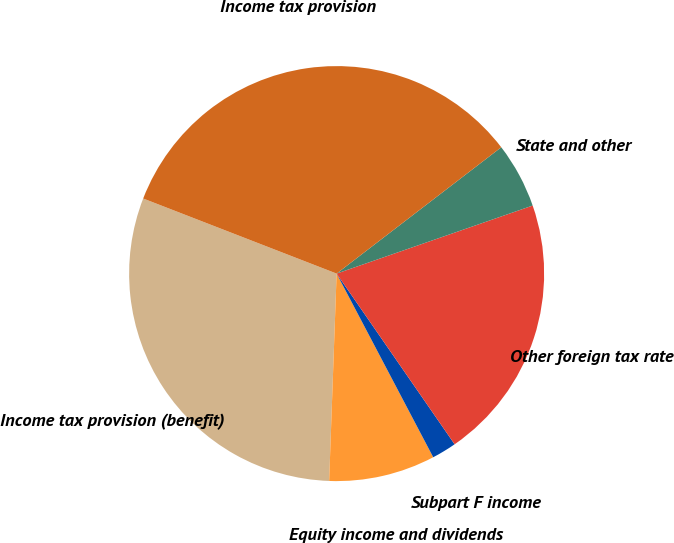Convert chart to OTSL. <chart><loc_0><loc_0><loc_500><loc_500><pie_chart><fcel>Income tax provision (benefit)<fcel>Equity income and dividends<fcel>Subpart F income<fcel>Other foreign tax rate<fcel>State and other<fcel>Income tax provision<nl><fcel>30.32%<fcel>8.28%<fcel>1.92%<fcel>20.69%<fcel>5.1%<fcel>33.69%<nl></chart> 